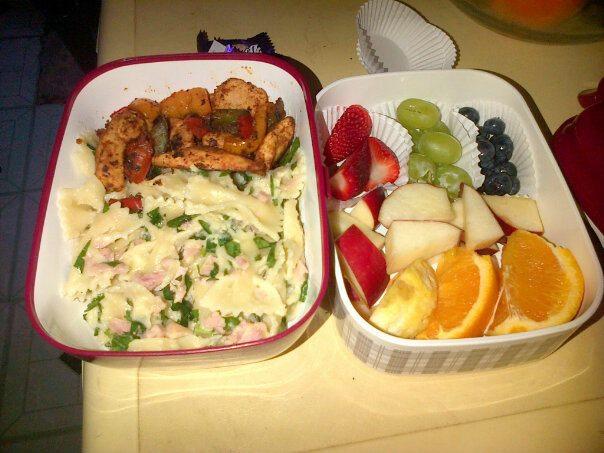What color container hold the meat?
Quick response, please. White. Which casserole has the raw food?
Keep it brief. Right. What kind of fruit is on the plate?
Give a very brief answer. Orange. Is there any fruit?
Concise answer only. Yes. What is the orange food called?
Answer briefly. Orange. Do the plates hold the same thing?
Quick response, please. No. Are there carrots?
Concise answer only. No. Which bowl has the healthier option to eat?
Answer briefly. Right. 